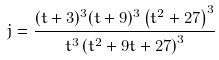<formula> <loc_0><loc_0><loc_500><loc_500>j = \frac { ( t + 3 ) ^ { 3 } ( t + 9 ) ^ { 3 } \left ( t ^ { 2 } + 2 7 \right ) ^ { 3 } } { t ^ { 3 } \left ( t ^ { 2 } + 9 t + 2 7 \right ) ^ { 3 } }</formula> 